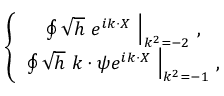Convert formula to latex. <formula><loc_0><loc_0><loc_500><loc_500>\left \{ \begin{array} { c } { { \oint \sqrt { h } \ e ^ { i k \cdot X } \ \right | _ { k ^ { 2 } = - 2 } \, , } } \\ { { \oint \sqrt { h } \ k \cdot \psi e ^ { i k \cdot X } \ \right | _ { k ^ { 2 } = - 1 } \, , } } \end{array}</formula> 